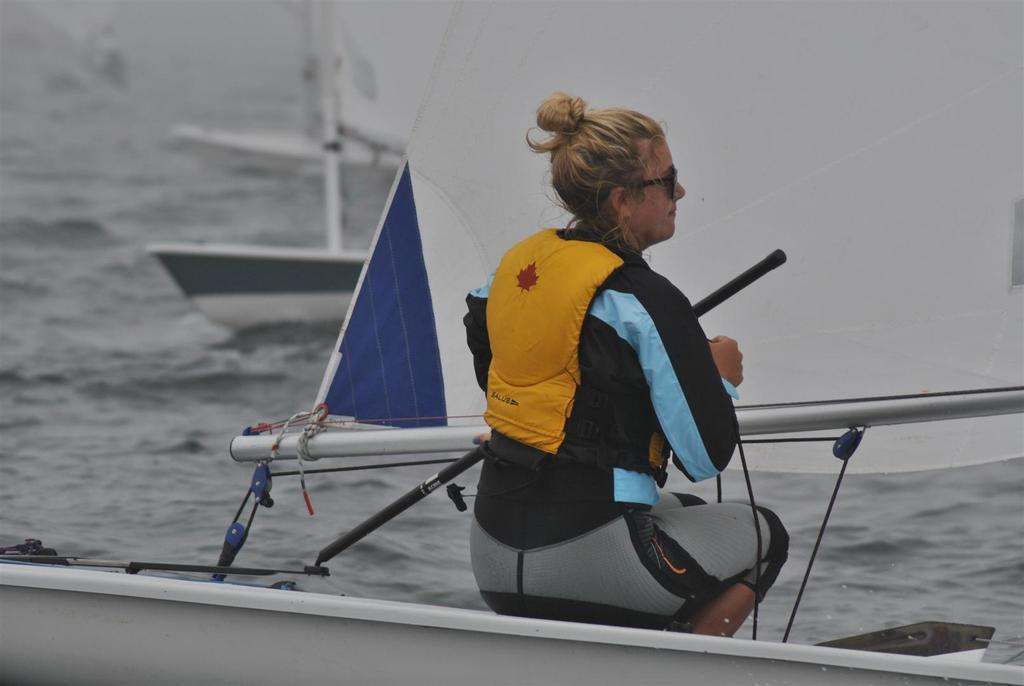Who is the main subject in the image? There is a woman in the image. What is the woman wearing? The woman is wearing a dress with yellow, grey, black, and blue colors. Where is the woman located in the image? The woman is sitting on a boat. What can be seen in the background of the image? There is water visible in the background of the image, and there are other boats as well. What type of apparatus is the woman using to have a discussion with her grandmother in the image? There is no apparatus or discussion with a grandmother present in the image. 